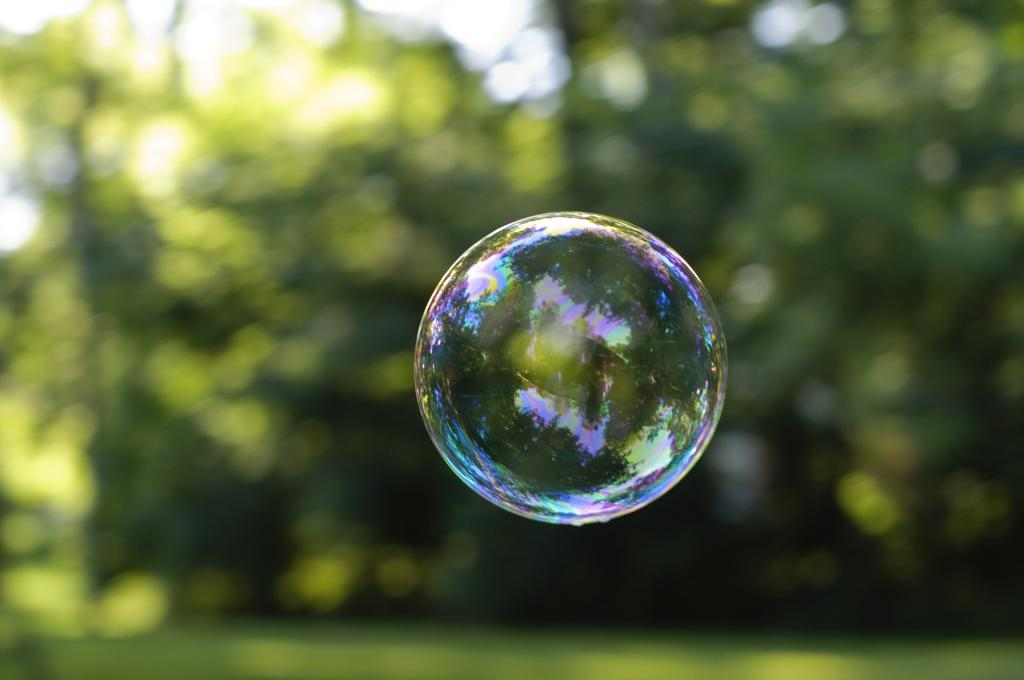What is the main feature in the front of the image? There is an air bubble in the front of the image. How would you describe the background of the image? The background of the image is blurry. What is the smell of the air bubble in the image? There is no smell associated with the air bubble in the image, as it is a visual representation and not a physical object. 